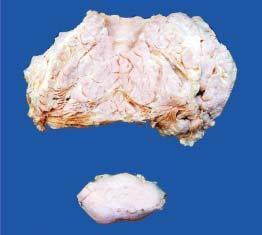s pidural haematoma multilobulated with increased fat while lower part of the image shows a separate encapsulated gelatinous mass?
Answer the question using a single word or phrase. No 